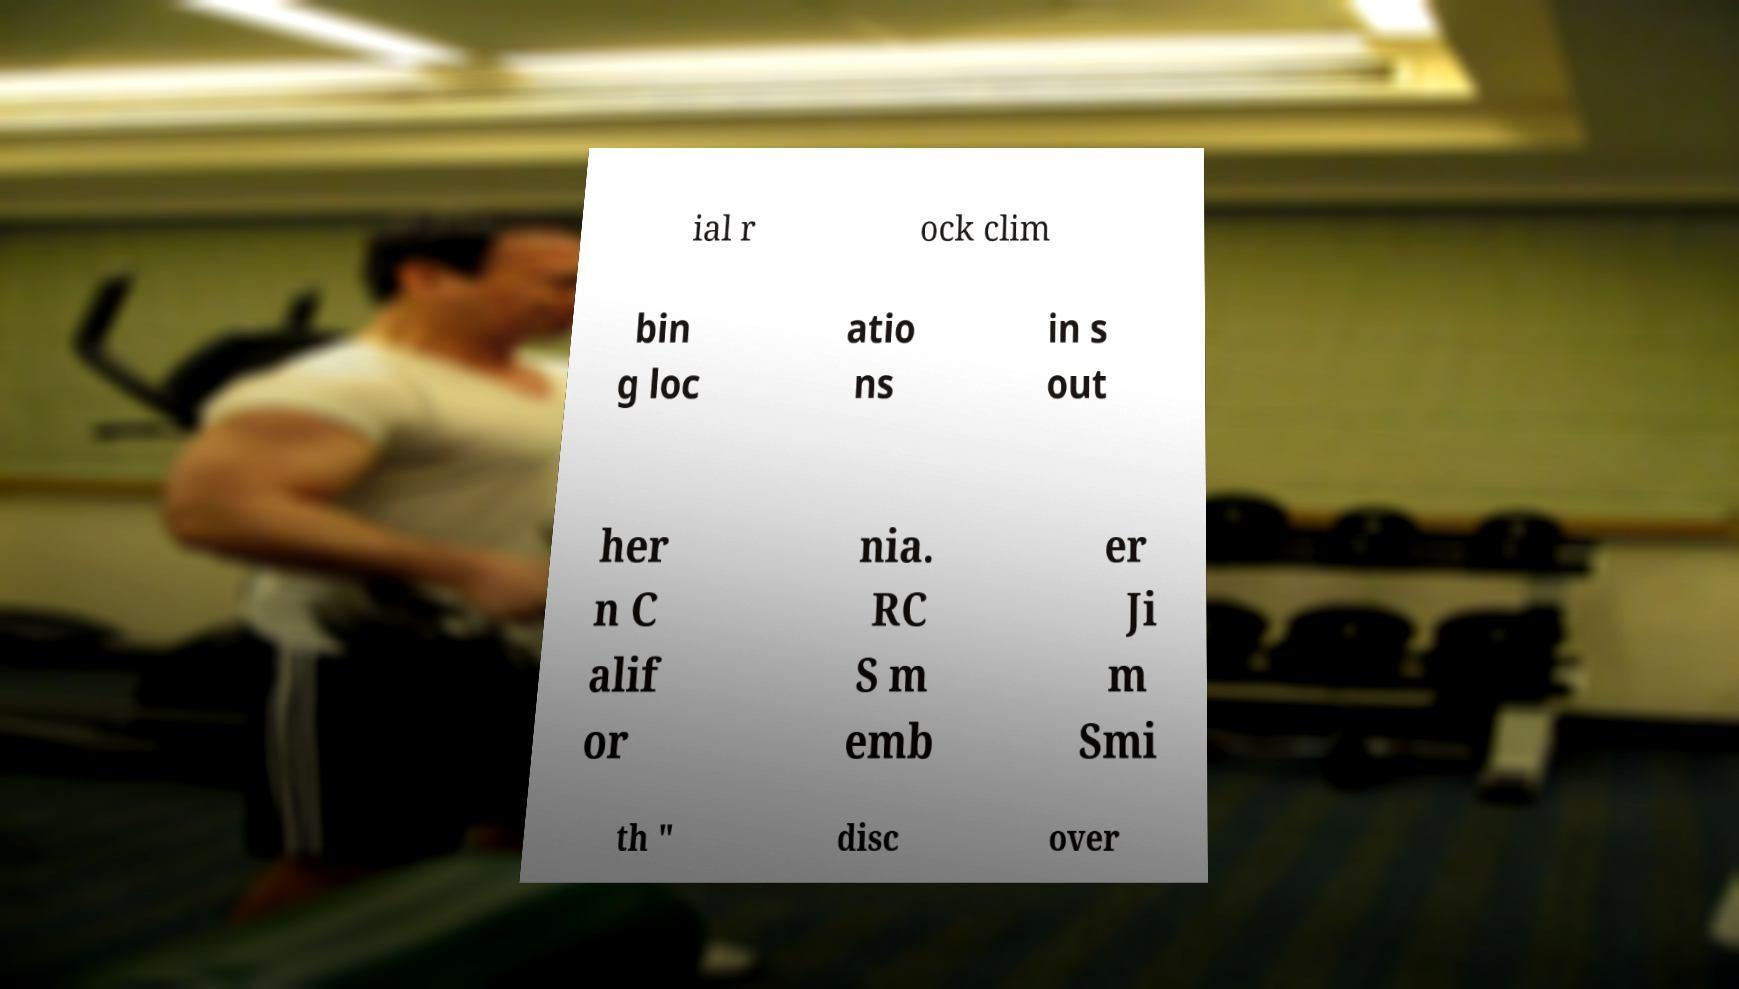Could you assist in decoding the text presented in this image and type it out clearly? ial r ock clim bin g loc atio ns in s out her n C alif or nia. RC S m emb er Ji m Smi th " disc over 